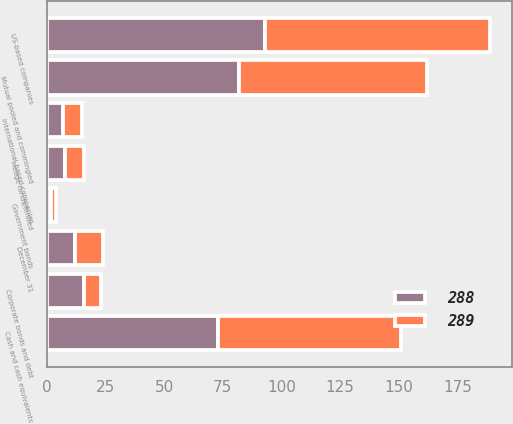<chart> <loc_0><loc_0><loc_500><loc_500><stacked_bar_chart><ecel><fcel>December 31<fcel>Cash and cash equivalents<fcel>US-based companies<fcel>International-based companies<fcel>Government bonds<fcel>Corporate bonds and debt<fcel>Mutual pooled and commingled<fcel>Hedge funds/limited<nl><fcel>288<fcel>12<fcel>73<fcel>93<fcel>7<fcel>2<fcel>16<fcel>82<fcel>8<nl><fcel>289<fcel>12<fcel>78<fcel>96<fcel>8<fcel>2<fcel>7<fcel>80<fcel>8<nl></chart> 